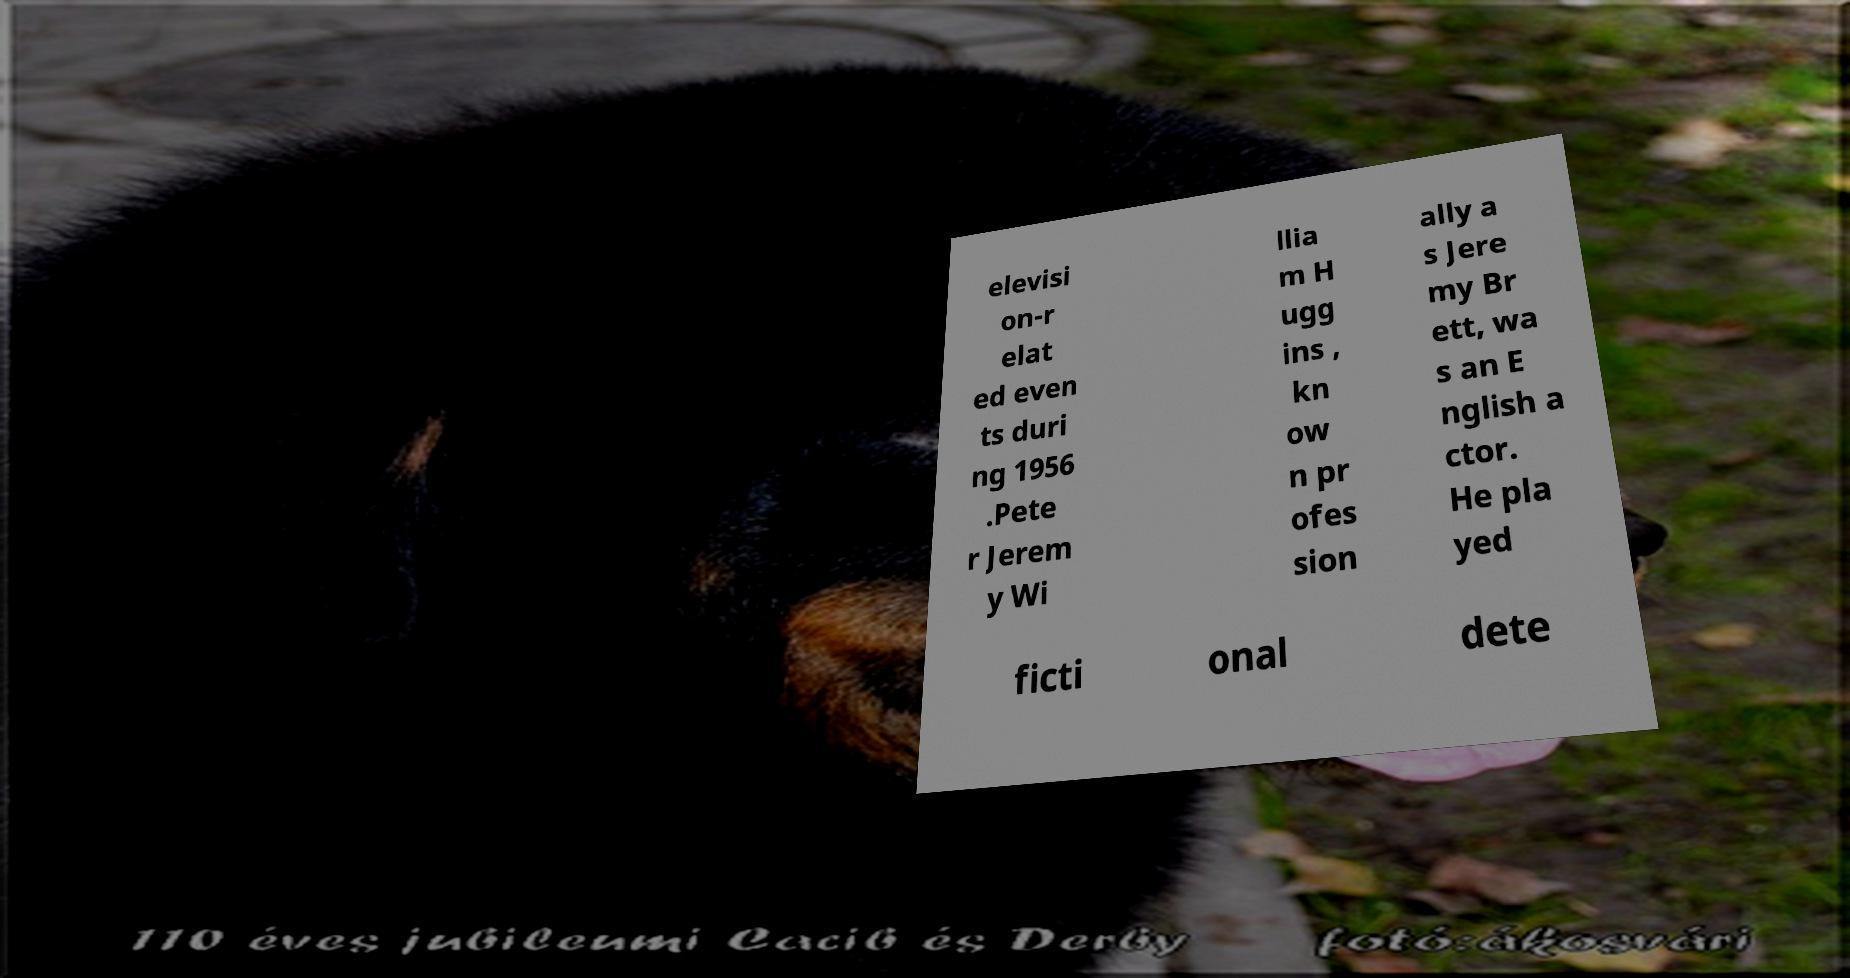I need the written content from this picture converted into text. Can you do that? elevisi on-r elat ed even ts duri ng 1956 .Pete r Jerem y Wi llia m H ugg ins , kn ow n pr ofes sion ally a s Jere my Br ett, wa s an E nglish a ctor. He pla yed ficti onal dete 